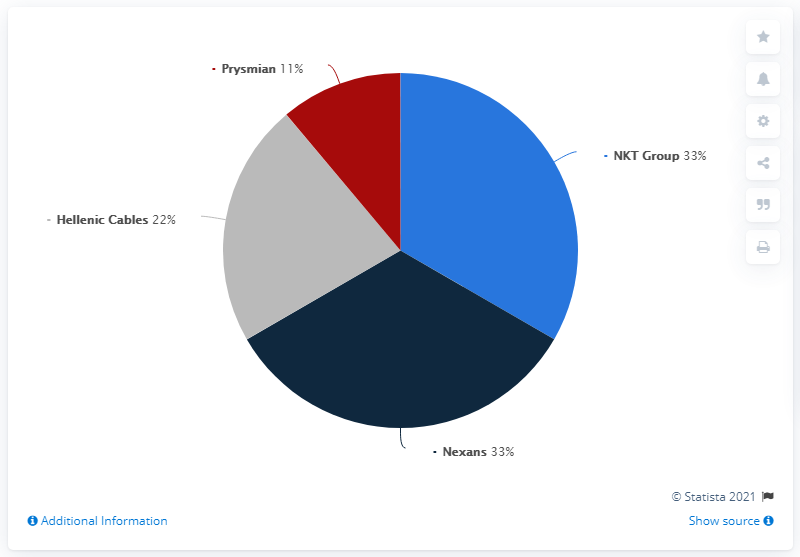Mention a couple of crucial points in this snapshot. The top three suppliers hold a combined market share of 88%. Nexans and NKT Group are the top 1 cable supplier. 